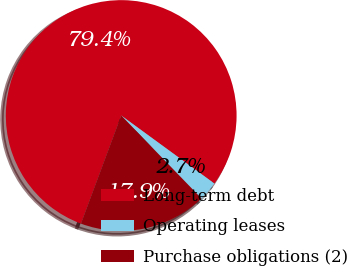Convert chart. <chart><loc_0><loc_0><loc_500><loc_500><pie_chart><fcel>Long-term debt<fcel>Operating leases<fcel>Purchase obligations (2)<nl><fcel>79.36%<fcel>2.73%<fcel>17.91%<nl></chart> 